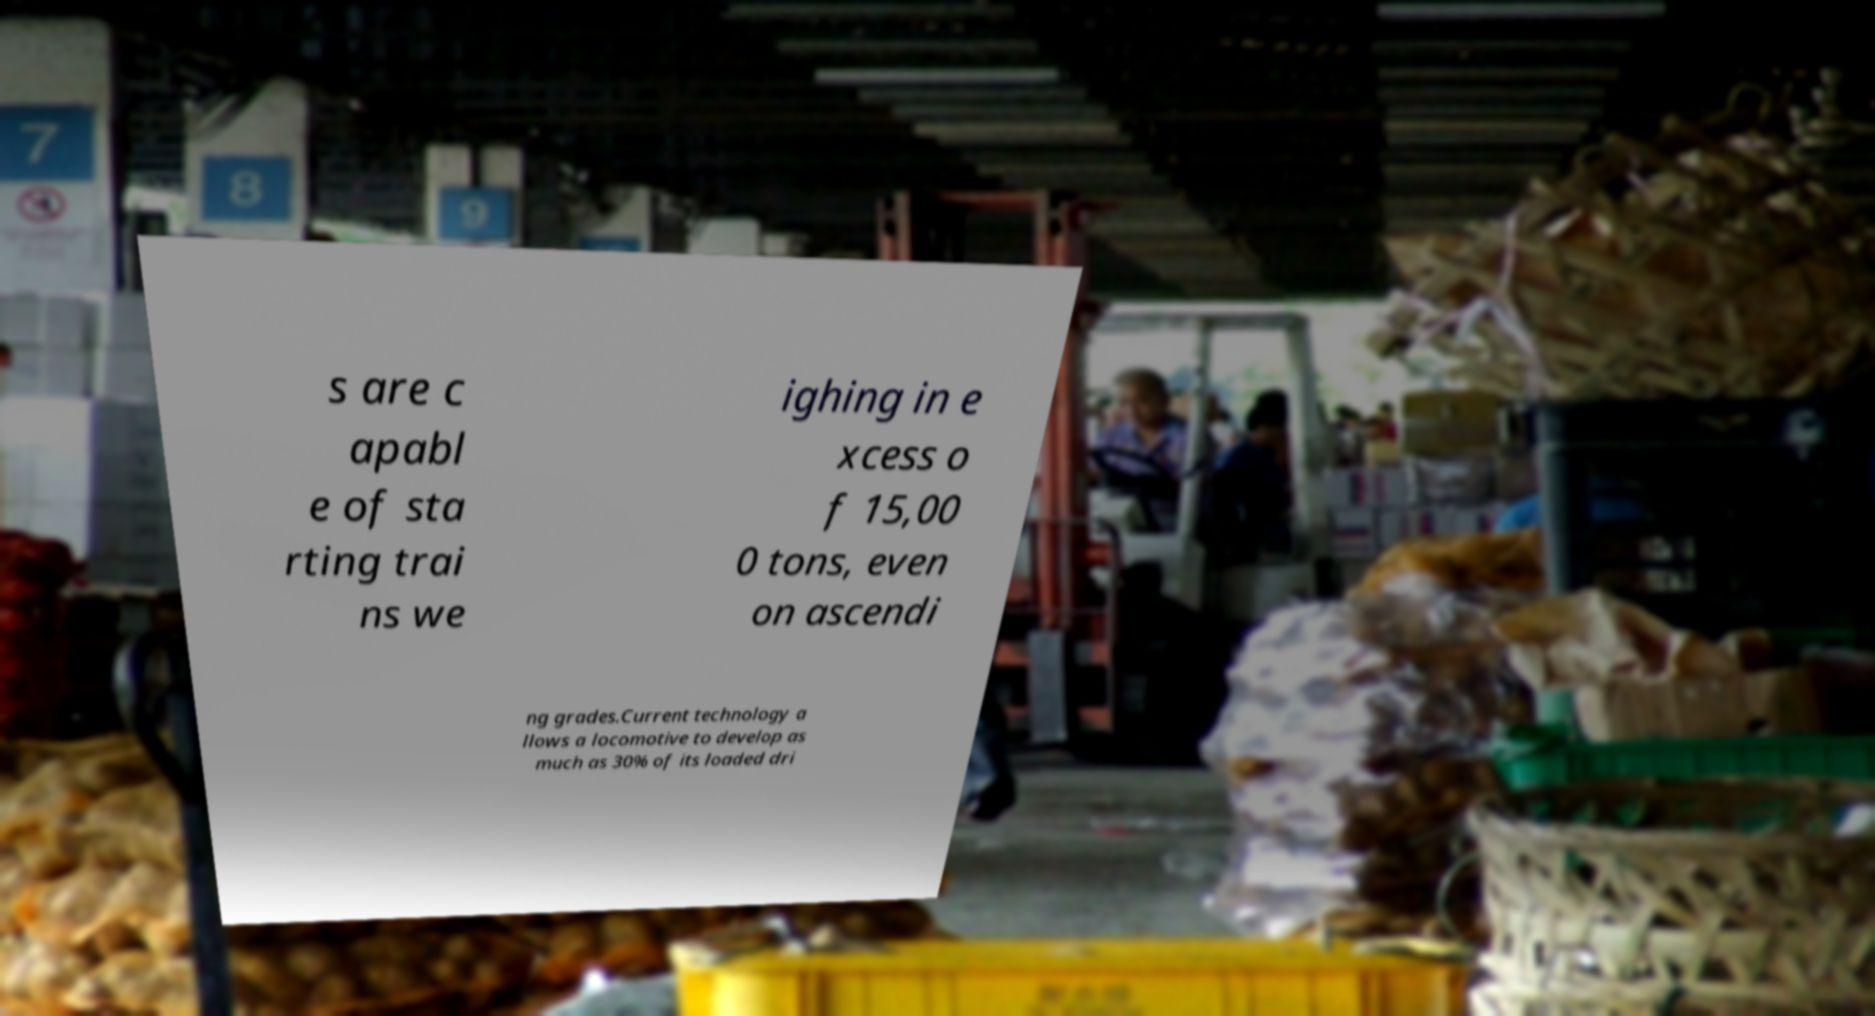What messages or text are displayed in this image? I need them in a readable, typed format. s are c apabl e of sta rting trai ns we ighing in e xcess o f 15,00 0 tons, even on ascendi ng grades.Current technology a llows a locomotive to develop as much as 30% of its loaded dri 